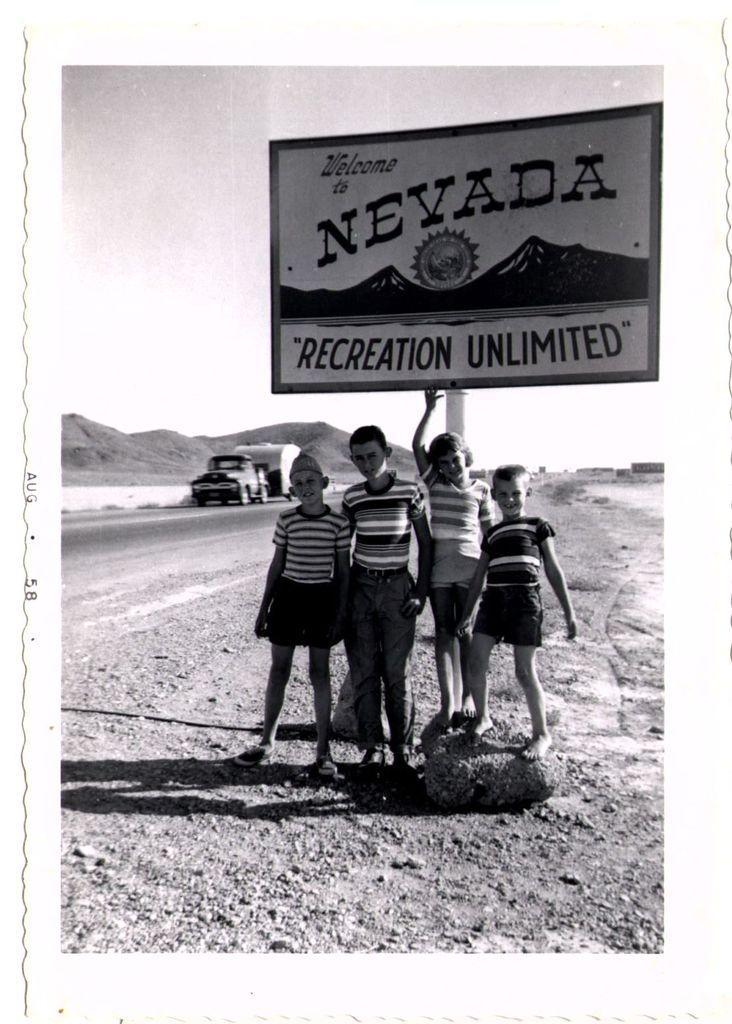Could you give a brief overview of what you see in this image? In this image there is a photograph. In this photograph there are children standing and we can see a board. There is a vehicle on the road. In the background there are hills and sky. 